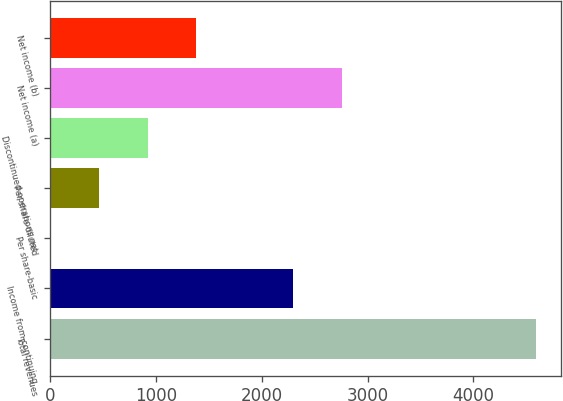Convert chart. <chart><loc_0><loc_0><loc_500><loc_500><bar_chart><fcel>Total revenues<fcel>Income from continuing<fcel>Per share-basic<fcel>Per share-diluted<fcel>Discontinued operations net<fcel>Net income (a)<fcel>Net income (b)<nl><fcel>4597<fcel>2298.96<fcel>0.96<fcel>460.56<fcel>920.16<fcel>2758.56<fcel>1379.76<nl></chart> 